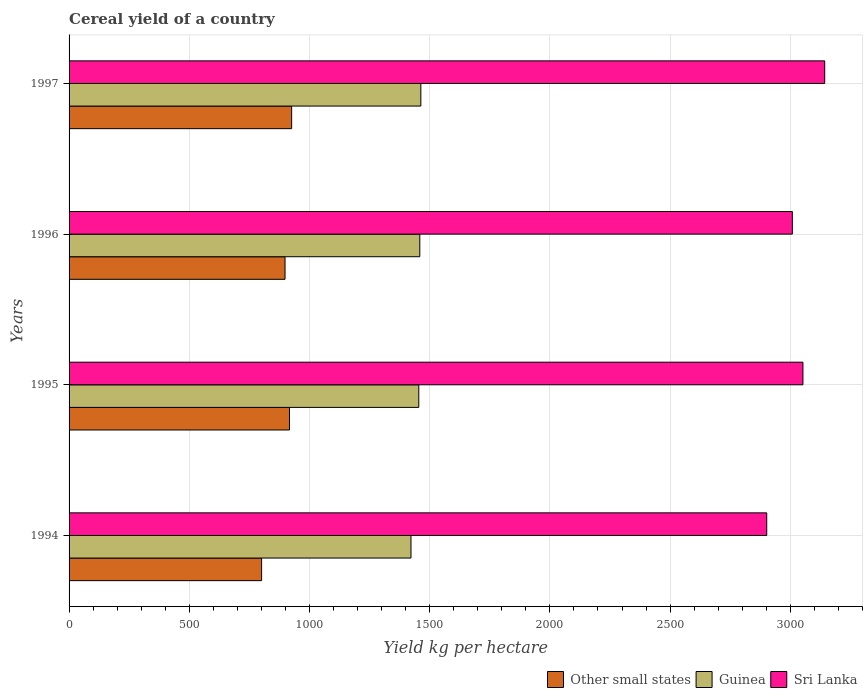How many different coloured bars are there?
Offer a terse response. 3. How many groups of bars are there?
Ensure brevity in your answer.  4. Are the number of bars per tick equal to the number of legend labels?
Your answer should be compact. Yes. Are the number of bars on each tick of the Y-axis equal?
Make the answer very short. Yes. How many bars are there on the 2nd tick from the top?
Your response must be concise. 3. How many bars are there on the 2nd tick from the bottom?
Your answer should be compact. 3. What is the total cereal yield in Sri Lanka in 1997?
Give a very brief answer. 3143.18. Across all years, what is the maximum total cereal yield in Sri Lanka?
Provide a succinct answer. 3143.18. Across all years, what is the minimum total cereal yield in Sri Lanka?
Ensure brevity in your answer.  2901.99. In which year was the total cereal yield in Sri Lanka minimum?
Keep it short and to the point. 1994. What is the total total cereal yield in Guinea in the graph?
Your answer should be compact. 5799.12. What is the difference between the total cereal yield in Guinea in 1996 and that in 1997?
Provide a short and direct response. -4.39. What is the difference between the total cereal yield in Guinea in 1996 and the total cereal yield in Other small states in 1995?
Keep it short and to the point. 542.04. What is the average total cereal yield in Guinea per year?
Make the answer very short. 1449.78. In the year 1996, what is the difference between the total cereal yield in Other small states and total cereal yield in Guinea?
Offer a terse response. -560.52. In how many years, is the total cereal yield in Other small states greater than 500 kg per hectare?
Your answer should be very brief. 4. What is the ratio of the total cereal yield in Sri Lanka in 1994 to that in 1996?
Keep it short and to the point. 0.96. What is the difference between the highest and the second highest total cereal yield in Other small states?
Offer a very short reply. 8.99. What is the difference between the highest and the lowest total cereal yield in Guinea?
Offer a very short reply. 40.98. In how many years, is the total cereal yield in Guinea greater than the average total cereal yield in Guinea taken over all years?
Keep it short and to the point. 3. Is the sum of the total cereal yield in Other small states in 1994 and 1997 greater than the maximum total cereal yield in Sri Lanka across all years?
Provide a succinct answer. No. What does the 2nd bar from the top in 1996 represents?
Provide a succinct answer. Guinea. What does the 3rd bar from the bottom in 1994 represents?
Offer a very short reply. Sri Lanka. How many bars are there?
Provide a succinct answer. 12. How many years are there in the graph?
Ensure brevity in your answer.  4. Does the graph contain any zero values?
Provide a short and direct response. No. Does the graph contain grids?
Provide a short and direct response. Yes. Where does the legend appear in the graph?
Ensure brevity in your answer.  Bottom right. How many legend labels are there?
Offer a very short reply. 3. What is the title of the graph?
Provide a succinct answer. Cereal yield of a country. Does "Albania" appear as one of the legend labels in the graph?
Your answer should be compact. No. What is the label or title of the X-axis?
Ensure brevity in your answer.  Yield kg per hectare. What is the label or title of the Y-axis?
Your answer should be very brief. Years. What is the Yield kg per hectare of Other small states in 1994?
Offer a very short reply. 800.92. What is the Yield kg per hectare of Guinea in 1994?
Your answer should be compact. 1422.26. What is the Yield kg per hectare of Sri Lanka in 1994?
Your answer should be very brief. 2901.99. What is the Yield kg per hectare in Other small states in 1995?
Your answer should be very brief. 916.82. What is the Yield kg per hectare of Guinea in 1995?
Provide a short and direct response. 1454.76. What is the Yield kg per hectare in Sri Lanka in 1995?
Offer a terse response. 3052.63. What is the Yield kg per hectare of Other small states in 1996?
Ensure brevity in your answer.  898.33. What is the Yield kg per hectare in Guinea in 1996?
Keep it short and to the point. 1458.86. What is the Yield kg per hectare in Sri Lanka in 1996?
Your answer should be compact. 3008.51. What is the Yield kg per hectare in Other small states in 1997?
Offer a terse response. 925.81. What is the Yield kg per hectare of Guinea in 1997?
Make the answer very short. 1463.24. What is the Yield kg per hectare in Sri Lanka in 1997?
Your response must be concise. 3143.18. Across all years, what is the maximum Yield kg per hectare in Other small states?
Offer a terse response. 925.81. Across all years, what is the maximum Yield kg per hectare in Guinea?
Your answer should be very brief. 1463.24. Across all years, what is the maximum Yield kg per hectare in Sri Lanka?
Your answer should be very brief. 3143.18. Across all years, what is the minimum Yield kg per hectare of Other small states?
Make the answer very short. 800.92. Across all years, what is the minimum Yield kg per hectare in Guinea?
Make the answer very short. 1422.26. Across all years, what is the minimum Yield kg per hectare in Sri Lanka?
Make the answer very short. 2901.99. What is the total Yield kg per hectare in Other small states in the graph?
Ensure brevity in your answer.  3541.87. What is the total Yield kg per hectare of Guinea in the graph?
Provide a succinct answer. 5799.12. What is the total Yield kg per hectare of Sri Lanka in the graph?
Keep it short and to the point. 1.21e+04. What is the difference between the Yield kg per hectare in Other small states in 1994 and that in 1995?
Give a very brief answer. -115.9. What is the difference between the Yield kg per hectare of Guinea in 1994 and that in 1995?
Keep it short and to the point. -32.5. What is the difference between the Yield kg per hectare in Sri Lanka in 1994 and that in 1995?
Your answer should be very brief. -150.63. What is the difference between the Yield kg per hectare in Other small states in 1994 and that in 1996?
Make the answer very short. -97.41. What is the difference between the Yield kg per hectare of Guinea in 1994 and that in 1996?
Offer a terse response. -36.6. What is the difference between the Yield kg per hectare of Sri Lanka in 1994 and that in 1996?
Provide a short and direct response. -106.52. What is the difference between the Yield kg per hectare of Other small states in 1994 and that in 1997?
Your answer should be very brief. -124.89. What is the difference between the Yield kg per hectare in Guinea in 1994 and that in 1997?
Make the answer very short. -40.98. What is the difference between the Yield kg per hectare in Sri Lanka in 1994 and that in 1997?
Make the answer very short. -241.18. What is the difference between the Yield kg per hectare of Other small states in 1995 and that in 1996?
Your answer should be compact. 18.48. What is the difference between the Yield kg per hectare in Guinea in 1995 and that in 1996?
Give a very brief answer. -4.1. What is the difference between the Yield kg per hectare in Sri Lanka in 1995 and that in 1996?
Ensure brevity in your answer.  44.12. What is the difference between the Yield kg per hectare of Other small states in 1995 and that in 1997?
Keep it short and to the point. -8.99. What is the difference between the Yield kg per hectare of Guinea in 1995 and that in 1997?
Offer a very short reply. -8.48. What is the difference between the Yield kg per hectare in Sri Lanka in 1995 and that in 1997?
Provide a succinct answer. -90.55. What is the difference between the Yield kg per hectare in Other small states in 1996 and that in 1997?
Your response must be concise. -27.47. What is the difference between the Yield kg per hectare in Guinea in 1996 and that in 1997?
Your answer should be compact. -4.39. What is the difference between the Yield kg per hectare in Sri Lanka in 1996 and that in 1997?
Your answer should be very brief. -134.66. What is the difference between the Yield kg per hectare of Other small states in 1994 and the Yield kg per hectare of Guinea in 1995?
Ensure brevity in your answer.  -653.84. What is the difference between the Yield kg per hectare of Other small states in 1994 and the Yield kg per hectare of Sri Lanka in 1995?
Ensure brevity in your answer.  -2251.71. What is the difference between the Yield kg per hectare of Guinea in 1994 and the Yield kg per hectare of Sri Lanka in 1995?
Offer a very short reply. -1630.37. What is the difference between the Yield kg per hectare in Other small states in 1994 and the Yield kg per hectare in Guinea in 1996?
Your answer should be very brief. -657.94. What is the difference between the Yield kg per hectare of Other small states in 1994 and the Yield kg per hectare of Sri Lanka in 1996?
Give a very brief answer. -2207.59. What is the difference between the Yield kg per hectare in Guinea in 1994 and the Yield kg per hectare in Sri Lanka in 1996?
Ensure brevity in your answer.  -1586.25. What is the difference between the Yield kg per hectare in Other small states in 1994 and the Yield kg per hectare in Guinea in 1997?
Your answer should be compact. -662.33. What is the difference between the Yield kg per hectare of Other small states in 1994 and the Yield kg per hectare of Sri Lanka in 1997?
Offer a terse response. -2342.26. What is the difference between the Yield kg per hectare of Guinea in 1994 and the Yield kg per hectare of Sri Lanka in 1997?
Provide a succinct answer. -1720.92. What is the difference between the Yield kg per hectare in Other small states in 1995 and the Yield kg per hectare in Guinea in 1996?
Offer a very short reply. -542.04. What is the difference between the Yield kg per hectare in Other small states in 1995 and the Yield kg per hectare in Sri Lanka in 1996?
Your answer should be compact. -2091.7. What is the difference between the Yield kg per hectare of Guinea in 1995 and the Yield kg per hectare of Sri Lanka in 1996?
Offer a terse response. -1553.75. What is the difference between the Yield kg per hectare of Other small states in 1995 and the Yield kg per hectare of Guinea in 1997?
Ensure brevity in your answer.  -546.43. What is the difference between the Yield kg per hectare in Other small states in 1995 and the Yield kg per hectare in Sri Lanka in 1997?
Offer a very short reply. -2226.36. What is the difference between the Yield kg per hectare in Guinea in 1995 and the Yield kg per hectare in Sri Lanka in 1997?
Your answer should be compact. -1688.42. What is the difference between the Yield kg per hectare of Other small states in 1996 and the Yield kg per hectare of Guinea in 1997?
Offer a terse response. -564.91. What is the difference between the Yield kg per hectare of Other small states in 1996 and the Yield kg per hectare of Sri Lanka in 1997?
Offer a terse response. -2244.84. What is the difference between the Yield kg per hectare in Guinea in 1996 and the Yield kg per hectare in Sri Lanka in 1997?
Your answer should be very brief. -1684.32. What is the average Yield kg per hectare of Other small states per year?
Make the answer very short. 885.47. What is the average Yield kg per hectare of Guinea per year?
Offer a terse response. 1449.78. What is the average Yield kg per hectare of Sri Lanka per year?
Your answer should be compact. 3026.58. In the year 1994, what is the difference between the Yield kg per hectare in Other small states and Yield kg per hectare in Guinea?
Offer a terse response. -621.34. In the year 1994, what is the difference between the Yield kg per hectare in Other small states and Yield kg per hectare in Sri Lanka?
Give a very brief answer. -2101.08. In the year 1994, what is the difference between the Yield kg per hectare of Guinea and Yield kg per hectare of Sri Lanka?
Your answer should be compact. -1479.74. In the year 1995, what is the difference between the Yield kg per hectare of Other small states and Yield kg per hectare of Guinea?
Make the answer very short. -537.94. In the year 1995, what is the difference between the Yield kg per hectare of Other small states and Yield kg per hectare of Sri Lanka?
Your response must be concise. -2135.81. In the year 1995, what is the difference between the Yield kg per hectare in Guinea and Yield kg per hectare in Sri Lanka?
Ensure brevity in your answer.  -1597.87. In the year 1996, what is the difference between the Yield kg per hectare in Other small states and Yield kg per hectare in Guinea?
Make the answer very short. -560.52. In the year 1996, what is the difference between the Yield kg per hectare in Other small states and Yield kg per hectare in Sri Lanka?
Offer a very short reply. -2110.18. In the year 1996, what is the difference between the Yield kg per hectare in Guinea and Yield kg per hectare in Sri Lanka?
Keep it short and to the point. -1549.66. In the year 1997, what is the difference between the Yield kg per hectare in Other small states and Yield kg per hectare in Guinea?
Ensure brevity in your answer.  -537.44. In the year 1997, what is the difference between the Yield kg per hectare of Other small states and Yield kg per hectare of Sri Lanka?
Provide a short and direct response. -2217.37. In the year 1997, what is the difference between the Yield kg per hectare in Guinea and Yield kg per hectare in Sri Lanka?
Provide a short and direct response. -1679.93. What is the ratio of the Yield kg per hectare of Other small states in 1994 to that in 1995?
Offer a terse response. 0.87. What is the ratio of the Yield kg per hectare of Guinea in 1994 to that in 1995?
Your answer should be very brief. 0.98. What is the ratio of the Yield kg per hectare of Sri Lanka in 1994 to that in 1995?
Provide a short and direct response. 0.95. What is the ratio of the Yield kg per hectare in Other small states in 1994 to that in 1996?
Provide a short and direct response. 0.89. What is the ratio of the Yield kg per hectare in Guinea in 1994 to that in 1996?
Offer a very short reply. 0.97. What is the ratio of the Yield kg per hectare of Sri Lanka in 1994 to that in 1996?
Keep it short and to the point. 0.96. What is the ratio of the Yield kg per hectare of Other small states in 1994 to that in 1997?
Make the answer very short. 0.87. What is the ratio of the Yield kg per hectare of Guinea in 1994 to that in 1997?
Your response must be concise. 0.97. What is the ratio of the Yield kg per hectare of Sri Lanka in 1994 to that in 1997?
Provide a succinct answer. 0.92. What is the ratio of the Yield kg per hectare in Other small states in 1995 to that in 1996?
Your answer should be compact. 1.02. What is the ratio of the Yield kg per hectare of Guinea in 1995 to that in 1996?
Keep it short and to the point. 1. What is the ratio of the Yield kg per hectare of Sri Lanka in 1995 to that in 1996?
Keep it short and to the point. 1.01. What is the ratio of the Yield kg per hectare of Other small states in 1995 to that in 1997?
Your answer should be compact. 0.99. What is the ratio of the Yield kg per hectare in Guinea in 1995 to that in 1997?
Give a very brief answer. 0.99. What is the ratio of the Yield kg per hectare of Sri Lanka in 1995 to that in 1997?
Make the answer very short. 0.97. What is the ratio of the Yield kg per hectare of Other small states in 1996 to that in 1997?
Your answer should be compact. 0.97. What is the ratio of the Yield kg per hectare of Sri Lanka in 1996 to that in 1997?
Your answer should be very brief. 0.96. What is the difference between the highest and the second highest Yield kg per hectare of Other small states?
Give a very brief answer. 8.99. What is the difference between the highest and the second highest Yield kg per hectare of Guinea?
Your answer should be compact. 4.39. What is the difference between the highest and the second highest Yield kg per hectare of Sri Lanka?
Give a very brief answer. 90.55. What is the difference between the highest and the lowest Yield kg per hectare of Other small states?
Your answer should be very brief. 124.89. What is the difference between the highest and the lowest Yield kg per hectare of Guinea?
Provide a succinct answer. 40.98. What is the difference between the highest and the lowest Yield kg per hectare in Sri Lanka?
Ensure brevity in your answer.  241.18. 